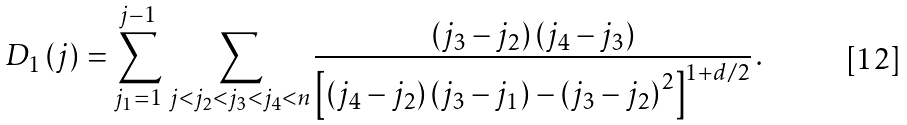<formula> <loc_0><loc_0><loc_500><loc_500>D _ { 1 } \left ( j \right ) = \sum ^ { j - 1 } _ { j _ { 1 } = 1 } \, \sum _ { j < j _ { 2 } < j _ { 3 } < j _ { 4 } < n } \frac { \left ( j _ { 3 } - j _ { 2 } \right ) \left ( j _ { 4 } - j _ { 3 } \right ) } { \left [ \left ( j _ { 4 } - j _ { 2 } \right ) \left ( j _ { 3 } - j _ { 1 } \right ) - \left ( j _ { 3 } - j _ { 2 } \right ) ^ { 2 } \right ] ^ { 1 + d / 2 } } \, .</formula> 